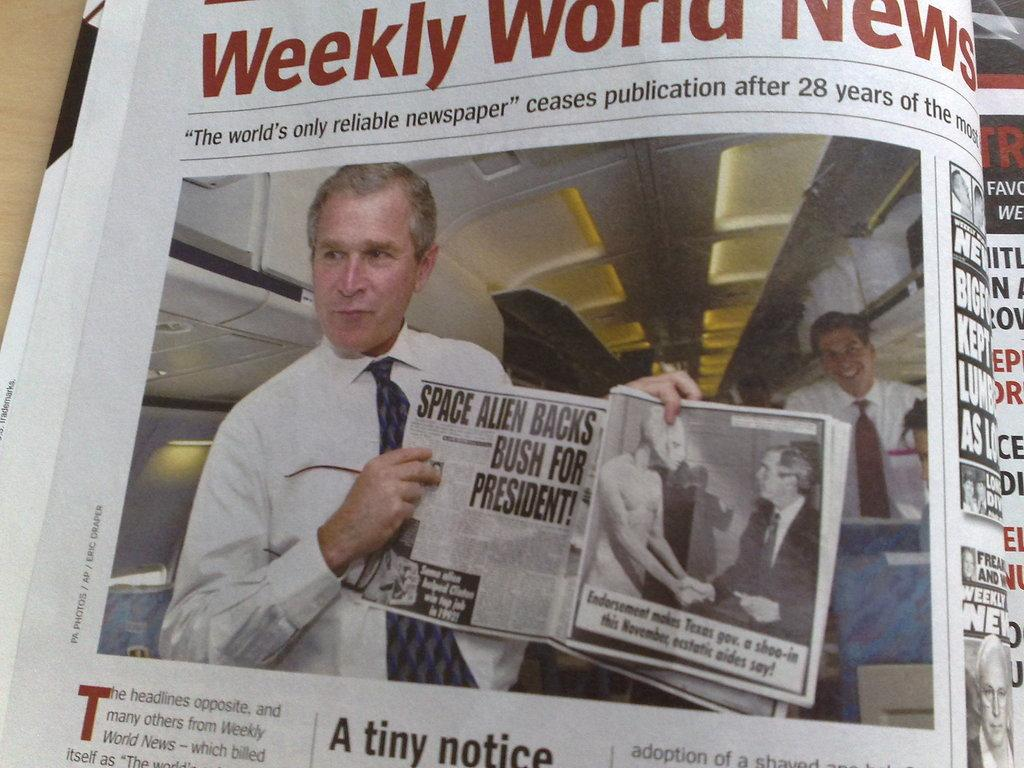What is the main subject of the image? The main subject of the image is a picture of a newspaper. What can be seen in the photograph on the newspaper? The photograph on the newspaper is of George W Bush. What else is present on the newspaper besides the photograph? There is text written on the newspaper. Can you see any needles in the image? No, there are no needles present in the image. What type of throat is visible in the image? There is no throat visible in the image; it features a picture of a newspaper with a photograph of George W Bush and text. 